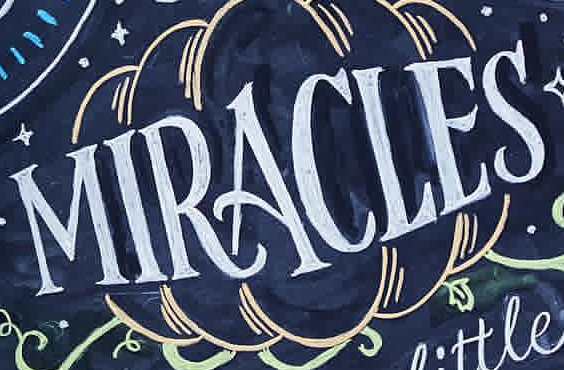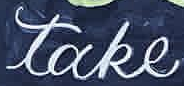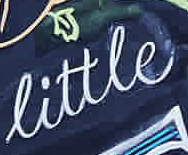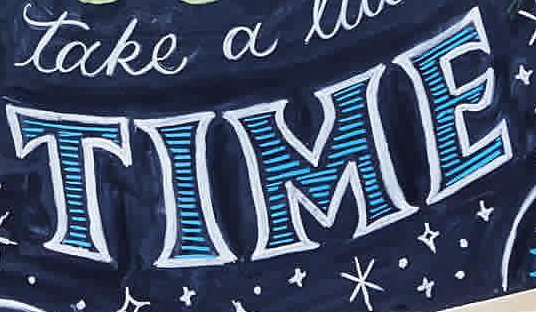Read the text content from these images in order, separated by a semicolon. MIRACLES; take; little; TIME 